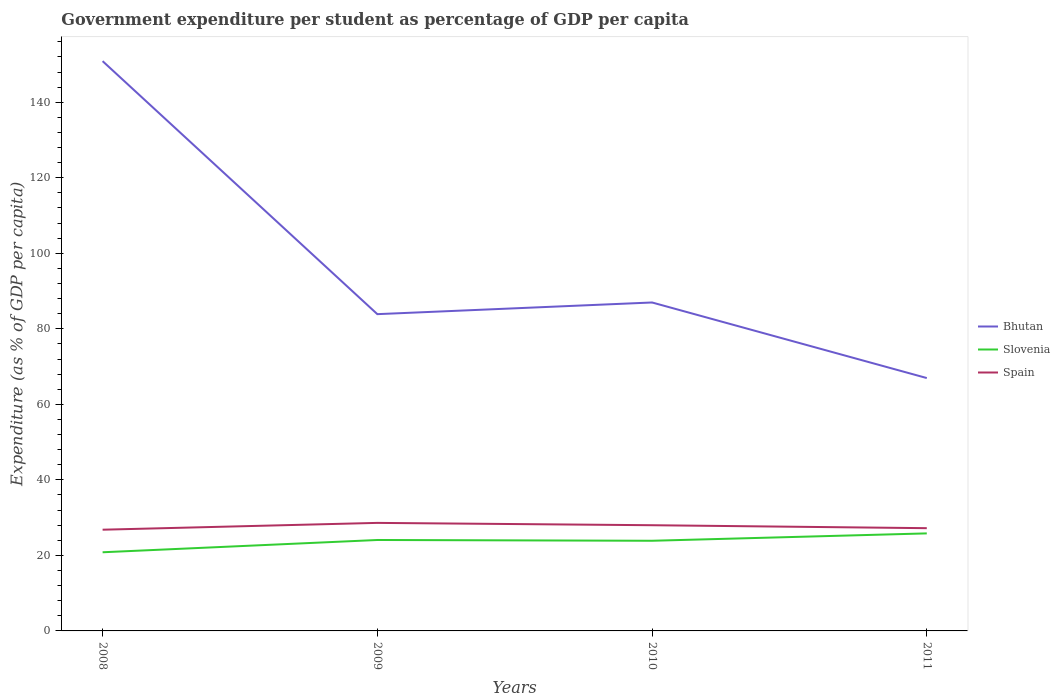Across all years, what is the maximum percentage of expenditure per student in Slovenia?
Provide a succinct answer. 20.83. In which year was the percentage of expenditure per student in Spain maximum?
Offer a very short reply. 2008. What is the total percentage of expenditure per student in Slovenia in the graph?
Keep it short and to the point. -1.75. What is the difference between the highest and the second highest percentage of expenditure per student in Bhutan?
Your answer should be very brief. 83.93. What is the difference between the highest and the lowest percentage of expenditure per student in Spain?
Your answer should be compact. 2. How many lines are there?
Offer a very short reply. 3. Are the values on the major ticks of Y-axis written in scientific E-notation?
Provide a succinct answer. No. Does the graph contain any zero values?
Offer a very short reply. No. Where does the legend appear in the graph?
Your answer should be very brief. Center right. How are the legend labels stacked?
Offer a very short reply. Vertical. What is the title of the graph?
Your answer should be compact. Government expenditure per student as percentage of GDP per capita. Does "Costa Rica" appear as one of the legend labels in the graph?
Provide a succinct answer. No. What is the label or title of the X-axis?
Make the answer very short. Years. What is the label or title of the Y-axis?
Your response must be concise. Expenditure (as % of GDP per capita). What is the Expenditure (as % of GDP per capita) in Bhutan in 2008?
Ensure brevity in your answer.  150.89. What is the Expenditure (as % of GDP per capita) of Slovenia in 2008?
Provide a short and direct response. 20.83. What is the Expenditure (as % of GDP per capita) in Spain in 2008?
Your answer should be compact. 26.8. What is the Expenditure (as % of GDP per capita) of Bhutan in 2009?
Your answer should be very brief. 83.89. What is the Expenditure (as % of GDP per capita) of Slovenia in 2009?
Ensure brevity in your answer.  24.08. What is the Expenditure (as % of GDP per capita) of Spain in 2009?
Offer a terse response. 28.61. What is the Expenditure (as % of GDP per capita) of Bhutan in 2010?
Make the answer very short. 86.98. What is the Expenditure (as % of GDP per capita) of Slovenia in 2010?
Keep it short and to the point. 23.88. What is the Expenditure (as % of GDP per capita) of Spain in 2010?
Your answer should be very brief. 27.99. What is the Expenditure (as % of GDP per capita) of Bhutan in 2011?
Give a very brief answer. 66.96. What is the Expenditure (as % of GDP per capita) of Slovenia in 2011?
Provide a short and direct response. 25.83. What is the Expenditure (as % of GDP per capita) in Spain in 2011?
Offer a terse response. 27.21. Across all years, what is the maximum Expenditure (as % of GDP per capita) in Bhutan?
Offer a terse response. 150.89. Across all years, what is the maximum Expenditure (as % of GDP per capita) of Slovenia?
Offer a terse response. 25.83. Across all years, what is the maximum Expenditure (as % of GDP per capita) in Spain?
Make the answer very short. 28.61. Across all years, what is the minimum Expenditure (as % of GDP per capita) of Bhutan?
Your answer should be compact. 66.96. Across all years, what is the minimum Expenditure (as % of GDP per capita) in Slovenia?
Give a very brief answer. 20.83. Across all years, what is the minimum Expenditure (as % of GDP per capita) of Spain?
Offer a terse response. 26.8. What is the total Expenditure (as % of GDP per capita) of Bhutan in the graph?
Offer a very short reply. 388.72. What is the total Expenditure (as % of GDP per capita) in Slovenia in the graph?
Your answer should be very brief. 94.61. What is the total Expenditure (as % of GDP per capita) in Spain in the graph?
Your answer should be very brief. 110.62. What is the difference between the Expenditure (as % of GDP per capita) in Bhutan in 2008 and that in 2009?
Provide a succinct answer. 67. What is the difference between the Expenditure (as % of GDP per capita) in Slovenia in 2008 and that in 2009?
Provide a short and direct response. -3.25. What is the difference between the Expenditure (as % of GDP per capita) in Spain in 2008 and that in 2009?
Make the answer very short. -1.81. What is the difference between the Expenditure (as % of GDP per capita) in Bhutan in 2008 and that in 2010?
Your response must be concise. 63.91. What is the difference between the Expenditure (as % of GDP per capita) in Slovenia in 2008 and that in 2010?
Give a very brief answer. -3.05. What is the difference between the Expenditure (as % of GDP per capita) of Spain in 2008 and that in 2010?
Your answer should be very brief. -1.19. What is the difference between the Expenditure (as % of GDP per capita) of Bhutan in 2008 and that in 2011?
Offer a very short reply. 83.93. What is the difference between the Expenditure (as % of GDP per capita) of Slovenia in 2008 and that in 2011?
Keep it short and to the point. -5. What is the difference between the Expenditure (as % of GDP per capita) in Spain in 2008 and that in 2011?
Offer a very short reply. -0.4. What is the difference between the Expenditure (as % of GDP per capita) in Bhutan in 2009 and that in 2010?
Provide a short and direct response. -3.09. What is the difference between the Expenditure (as % of GDP per capita) in Slovenia in 2009 and that in 2010?
Your response must be concise. 0.2. What is the difference between the Expenditure (as % of GDP per capita) of Spain in 2009 and that in 2010?
Your answer should be very brief. 0.62. What is the difference between the Expenditure (as % of GDP per capita) in Bhutan in 2009 and that in 2011?
Your answer should be very brief. 16.92. What is the difference between the Expenditure (as % of GDP per capita) of Slovenia in 2009 and that in 2011?
Your answer should be compact. -1.75. What is the difference between the Expenditure (as % of GDP per capita) of Spain in 2009 and that in 2011?
Keep it short and to the point. 1.4. What is the difference between the Expenditure (as % of GDP per capita) in Bhutan in 2010 and that in 2011?
Your response must be concise. 20.01. What is the difference between the Expenditure (as % of GDP per capita) in Slovenia in 2010 and that in 2011?
Your answer should be compact. -1.95. What is the difference between the Expenditure (as % of GDP per capita) of Spain in 2010 and that in 2011?
Your answer should be very brief. 0.79. What is the difference between the Expenditure (as % of GDP per capita) of Bhutan in 2008 and the Expenditure (as % of GDP per capita) of Slovenia in 2009?
Your answer should be compact. 126.81. What is the difference between the Expenditure (as % of GDP per capita) in Bhutan in 2008 and the Expenditure (as % of GDP per capita) in Spain in 2009?
Make the answer very short. 122.28. What is the difference between the Expenditure (as % of GDP per capita) of Slovenia in 2008 and the Expenditure (as % of GDP per capita) of Spain in 2009?
Your answer should be very brief. -7.78. What is the difference between the Expenditure (as % of GDP per capita) of Bhutan in 2008 and the Expenditure (as % of GDP per capita) of Slovenia in 2010?
Provide a succinct answer. 127.01. What is the difference between the Expenditure (as % of GDP per capita) in Bhutan in 2008 and the Expenditure (as % of GDP per capita) in Spain in 2010?
Ensure brevity in your answer.  122.9. What is the difference between the Expenditure (as % of GDP per capita) of Slovenia in 2008 and the Expenditure (as % of GDP per capita) of Spain in 2010?
Your answer should be very brief. -7.16. What is the difference between the Expenditure (as % of GDP per capita) of Bhutan in 2008 and the Expenditure (as % of GDP per capita) of Slovenia in 2011?
Keep it short and to the point. 125.06. What is the difference between the Expenditure (as % of GDP per capita) of Bhutan in 2008 and the Expenditure (as % of GDP per capita) of Spain in 2011?
Your response must be concise. 123.68. What is the difference between the Expenditure (as % of GDP per capita) of Slovenia in 2008 and the Expenditure (as % of GDP per capita) of Spain in 2011?
Your answer should be very brief. -6.38. What is the difference between the Expenditure (as % of GDP per capita) in Bhutan in 2009 and the Expenditure (as % of GDP per capita) in Slovenia in 2010?
Your answer should be compact. 60.01. What is the difference between the Expenditure (as % of GDP per capita) in Bhutan in 2009 and the Expenditure (as % of GDP per capita) in Spain in 2010?
Keep it short and to the point. 55.89. What is the difference between the Expenditure (as % of GDP per capita) in Slovenia in 2009 and the Expenditure (as % of GDP per capita) in Spain in 2010?
Offer a very short reply. -3.91. What is the difference between the Expenditure (as % of GDP per capita) in Bhutan in 2009 and the Expenditure (as % of GDP per capita) in Slovenia in 2011?
Make the answer very short. 58.06. What is the difference between the Expenditure (as % of GDP per capita) in Bhutan in 2009 and the Expenditure (as % of GDP per capita) in Spain in 2011?
Offer a terse response. 56.68. What is the difference between the Expenditure (as % of GDP per capita) of Slovenia in 2009 and the Expenditure (as % of GDP per capita) of Spain in 2011?
Your answer should be very brief. -3.13. What is the difference between the Expenditure (as % of GDP per capita) in Bhutan in 2010 and the Expenditure (as % of GDP per capita) in Slovenia in 2011?
Your answer should be compact. 61.15. What is the difference between the Expenditure (as % of GDP per capita) of Bhutan in 2010 and the Expenditure (as % of GDP per capita) of Spain in 2011?
Offer a very short reply. 59.77. What is the difference between the Expenditure (as % of GDP per capita) in Slovenia in 2010 and the Expenditure (as % of GDP per capita) in Spain in 2011?
Your response must be concise. -3.33. What is the average Expenditure (as % of GDP per capita) of Bhutan per year?
Make the answer very short. 97.18. What is the average Expenditure (as % of GDP per capita) in Slovenia per year?
Offer a terse response. 23.65. What is the average Expenditure (as % of GDP per capita) of Spain per year?
Offer a very short reply. 27.65. In the year 2008, what is the difference between the Expenditure (as % of GDP per capita) in Bhutan and Expenditure (as % of GDP per capita) in Slovenia?
Provide a succinct answer. 130.06. In the year 2008, what is the difference between the Expenditure (as % of GDP per capita) in Bhutan and Expenditure (as % of GDP per capita) in Spain?
Offer a very short reply. 124.09. In the year 2008, what is the difference between the Expenditure (as % of GDP per capita) in Slovenia and Expenditure (as % of GDP per capita) in Spain?
Your response must be concise. -5.97. In the year 2009, what is the difference between the Expenditure (as % of GDP per capita) of Bhutan and Expenditure (as % of GDP per capita) of Slovenia?
Ensure brevity in your answer.  59.81. In the year 2009, what is the difference between the Expenditure (as % of GDP per capita) in Bhutan and Expenditure (as % of GDP per capita) in Spain?
Make the answer very short. 55.28. In the year 2009, what is the difference between the Expenditure (as % of GDP per capita) in Slovenia and Expenditure (as % of GDP per capita) in Spain?
Make the answer very short. -4.53. In the year 2010, what is the difference between the Expenditure (as % of GDP per capita) of Bhutan and Expenditure (as % of GDP per capita) of Slovenia?
Keep it short and to the point. 63.1. In the year 2010, what is the difference between the Expenditure (as % of GDP per capita) of Bhutan and Expenditure (as % of GDP per capita) of Spain?
Make the answer very short. 58.98. In the year 2010, what is the difference between the Expenditure (as % of GDP per capita) in Slovenia and Expenditure (as % of GDP per capita) in Spain?
Your answer should be compact. -4.12. In the year 2011, what is the difference between the Expenditure (as % of GDP per capita) in Bhutan and Expenditure (as % of GDP per capita) in Slovenia?
Keep it short and to the point. 41.13. In the year 2011, what is the difference between the Expenditure (as % of GDP per capita) in Bhutan and Expenditure (as % of GDP per capita) in Spain?
Make the answer very short. 39.75. In the year 2011, what is the difference between the Expenditure (as % of GDP per capita) in Slovenia and Expenditure (as % of GDP per capita) in Spain?
Ensure brevity in your answer.  -1.38. What is the ratio of the Expenditure (as % of GDP per capita) in Bhutan in 2008 to that in 2009?
Ensure brevity in your answer.  1.8. What is the ratio of the Expenditure (as % of GDP per capita) of Slovenia in 2008 to that in 2009?
Your answer should be very brief. 0.86. What is the ratio of the Expenditure (as % of GDP per capita) in Spain in 2008 to that in 2009?
Offer a terse response. 0.94. What is the ratio of the Expenditure (as % of GDP per capita) of Bhutan in 2008 to that in 2010?
Your answer should be very brief. 1.73. What is the ratio of the Expenditure (as % of GDP per capita) of Slovenia in 2008 to that in 2010?
Offer a terse response. 0.87. What is the ratio of the Expenditure (as % of GDP per capita) in Spain in 2008 to that in 2010?
Provide a succinct answer. 0.96. What is the ratio of the Expenditure (as % of GDP per capita) in Bhutan in 2008 to that in 2011?
Provide a short and direct response. 2.25. What is the ratio of the Expenditure (as % of GDP per capita) in Slovenia in 2008 to that in 2011?
Provide a succinct answer. 0.81. What is the ratio of the Expenditure (as % of GDP per capita) in Spain in 2008 to that in 2011?
Offer a very short reply. 0.99. What is the ratio of the Expenditure (as % of GDP per capita) of Bhutan in 2009 to that in 2010?
Your answer should be very brief. 0.96. What is the ratio of the Expenditure (as % of GDP per capita) in Slovenia in 2009 to that in 2010?
Keep it short and to the point. 1.01. What is the ratio of the Expenditure (as % of GDP per capita) in Bhutan in 2009 to that in 2011?
Offer a terse response. 1.25. What is the ratio of the Expenditure (as % of GDP per capita) in Slovenia in 2009 to that in 2011?
Ensure brevity in your answer.  0.93. What is the ratio of the Expenditure (as % of GDP per capita) of Spain in 2009 to that in 2011?
Keep it short and to the point. 1.05. What is the ratio of the Expenditure (as % of GDP per capita) of Bhutan in 2010 to that in 2011?
Your answer should be very brief. 1.3. What is the ratio of the Expenditure (as % of GDP per capita) in Slovenia in 2010 to that in 2011?
Make the answer very short. 0.92. What is the ratio of the Expenditure (as % of GDP per capita) of Spain in 2010 to that in 2011?
Give a very brief answer. 1.03. What is the difference between the highest and the second highest Expenditure (as % of GDP per capita) in Bhutan?
Your response must be concise. 63.91. What is the difference between the highest and the second highest Expenditure (as % of GDP per capita) of Slovenia?
Make the answer very short. 1.75. What is the difference between the highest and the second highest Expenditure (as % of GDP per capita) of Spain?
Your answer should be compact. 0.62. What is the difference between the highest and the lowest Expenditure (as % of GDP per capita) of Bhutan?
Make the answer very short. 83.93. What is the difference between the highest and the lowest Expenditure (as % of GDP per capita) in Slovenia?
Offer a very short reply. 5. What is the difference between the highest and the lowest Expenditure (as % of GDP per capita) in Spain?
Your response must be concise. 1.81. 